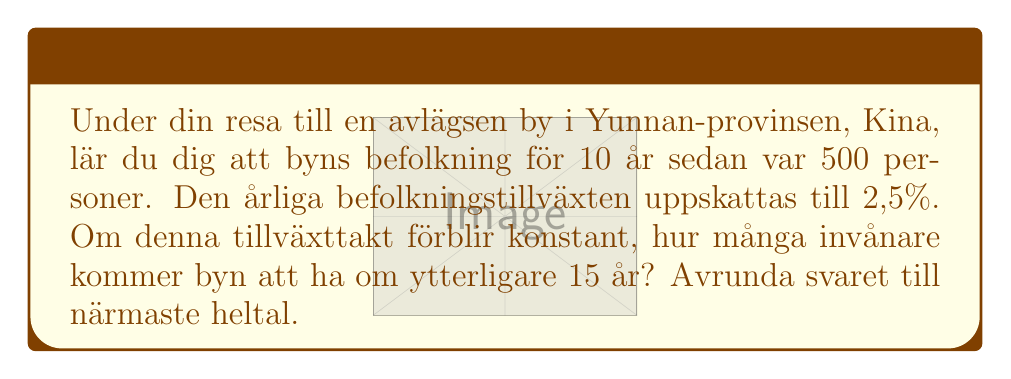Provide a solution to this math problem. För att lösa detta problem använder vi en exponentiell tillväxtfunktion:

$$P(t) = P_0 \cdot (1 + r)^t$$

Där:
$P(t)$ är populationen efter $t$ år
$P_0$ är den ursprungliga populationen
$r$ är den årliga tillväxttakten (i decimalform)
$t$ är antalet år

Steg 1: Identifiera givna värden
$P_0 = 500$ (populationen för 10 år sedan)
$r = 0.025$ (2,5% = 0.025 i decimalform)
$t = 25$ (10 år sedan till nu + 15 år framåt)

Steg 2: Sätt in värdena i formeln
$$P(25) = 500 \cdot (1 + 0.025)^{25}$$

Steg 3: Beräkna
$$P(25) = 500 \cdot (1.025)^{25}$$
$$P(25) = 500 \cdot 1.854926604$$
$$P(25) = 927.4633022$$

Steg 4: Avrunda till närmaste heltal
$$P(25) \approx 927$$
Answer: 927 invånare 